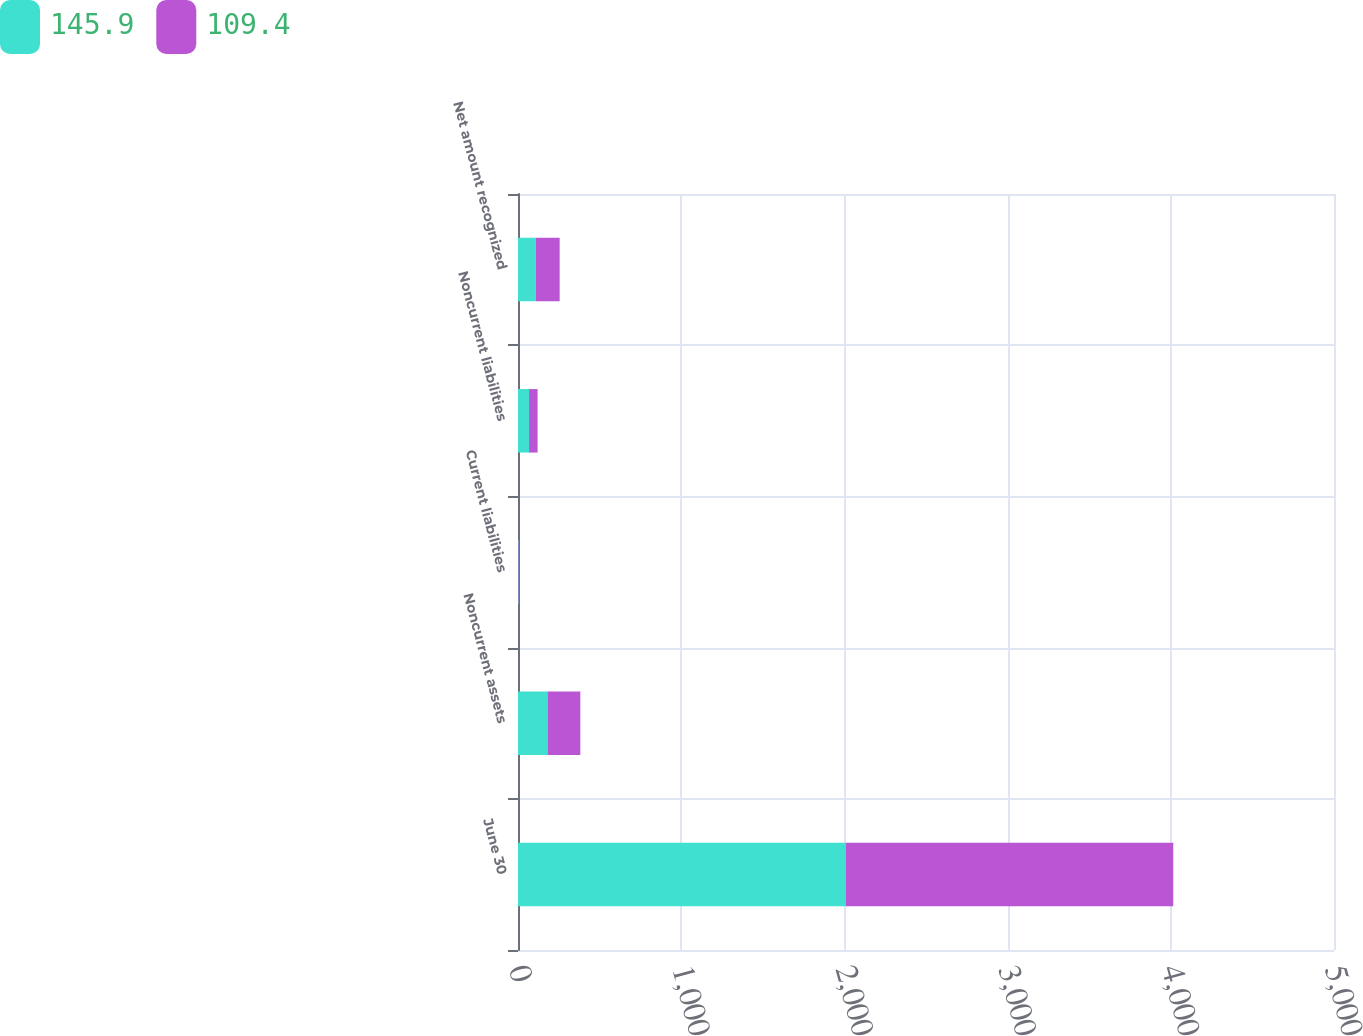Convert chart. <chart><loc_0><loc_0><loc_500><loc_500><stacked_bar_chart><ecel><fcel>June 30<fcel>Noncurrent assets<fcel>Current liabilities<fcel>Noncurrent liabilities<fcel>Net amount recognized<nl><fcel>145.9<fcel>2008<fcel>180.6<fcel>3.6<fcel>67.6<fcel>109.4<nl><fcel>109.4<fcel>2007<fcel>201.3<fcel>2.9<fcel>52.5<fcel>145.9<nl></chart> 